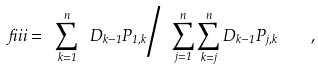Convert formula to latex. <formula><loc_0><loc_0><loc_500><loc_500>\ f i i i = \ \sum _ { k = 1 } ^ { n } \ D _ { k - 1 } P _ { 1 , k } \Big / \ \sum _ { j = 1 } ^ { n } \sum _ { k = j } ^ { n } D _ { k - 1 } P _ { j , k } \quad ,</formula> 